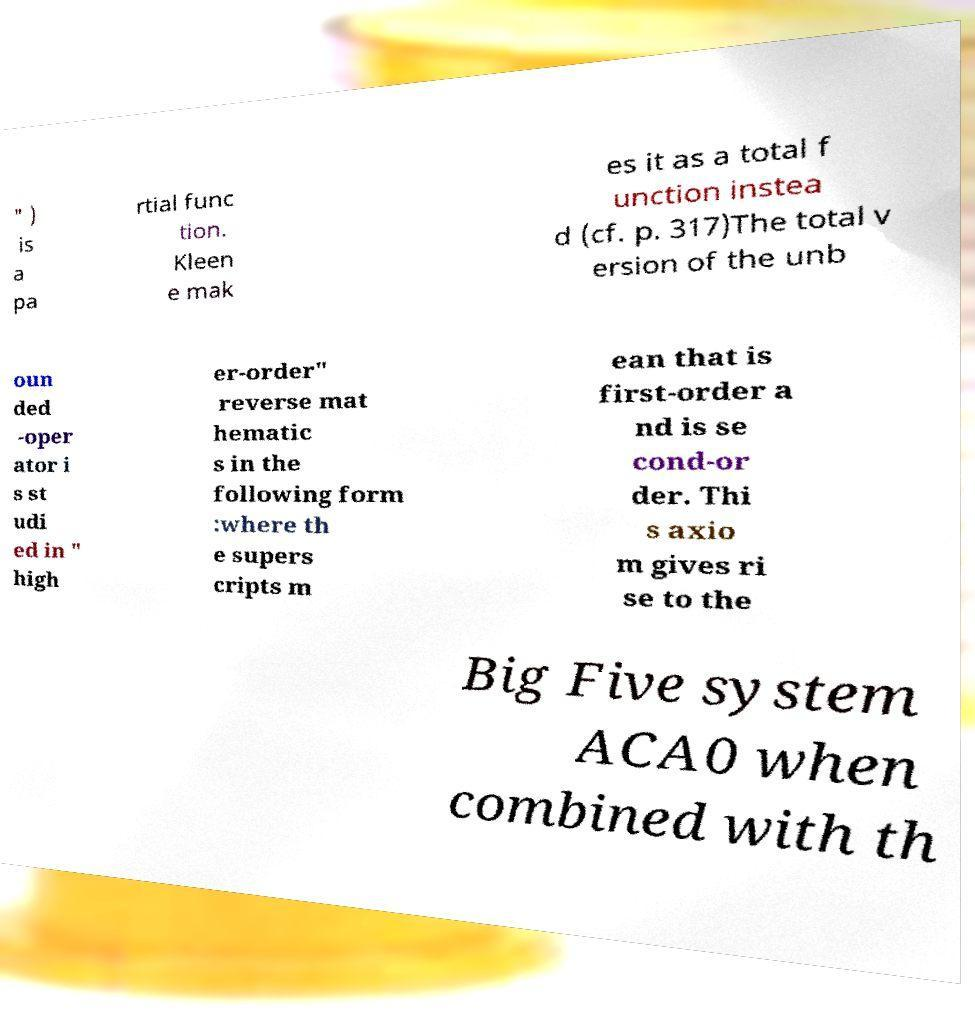For documentation purposes, I need the text within this image transcribed. Could you provide that? " ) is a pa rtial func tion. Kleen e mak es it as a total f unction instea d (cf. p. 317)The total v ersion of the unb oun ded -oper ator i s st udi ed in " high er-order" reverse mat hematic s in the following form :where th e supers cripts m ean that is first-order a nd is se cond-or der. Thi s axio m gives ri se to the Big Five system ACA0 when combined with th 